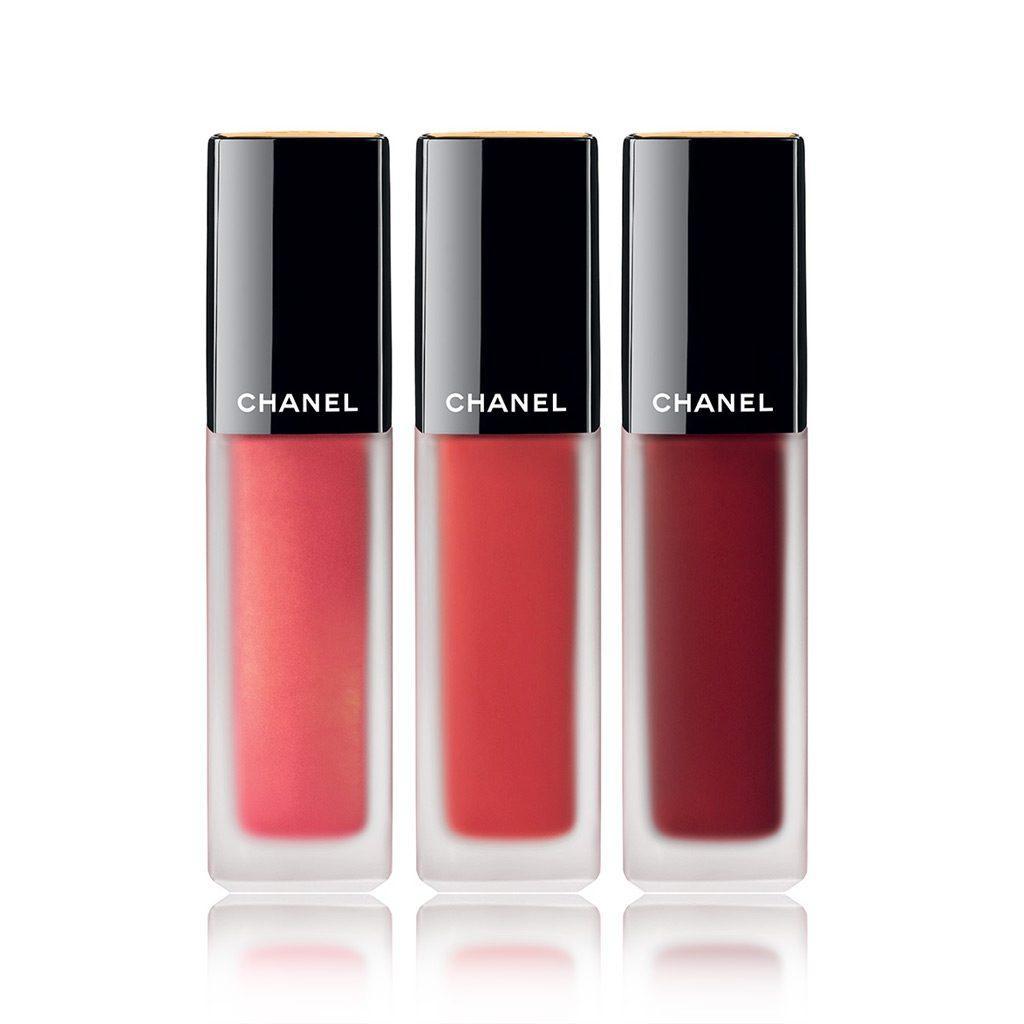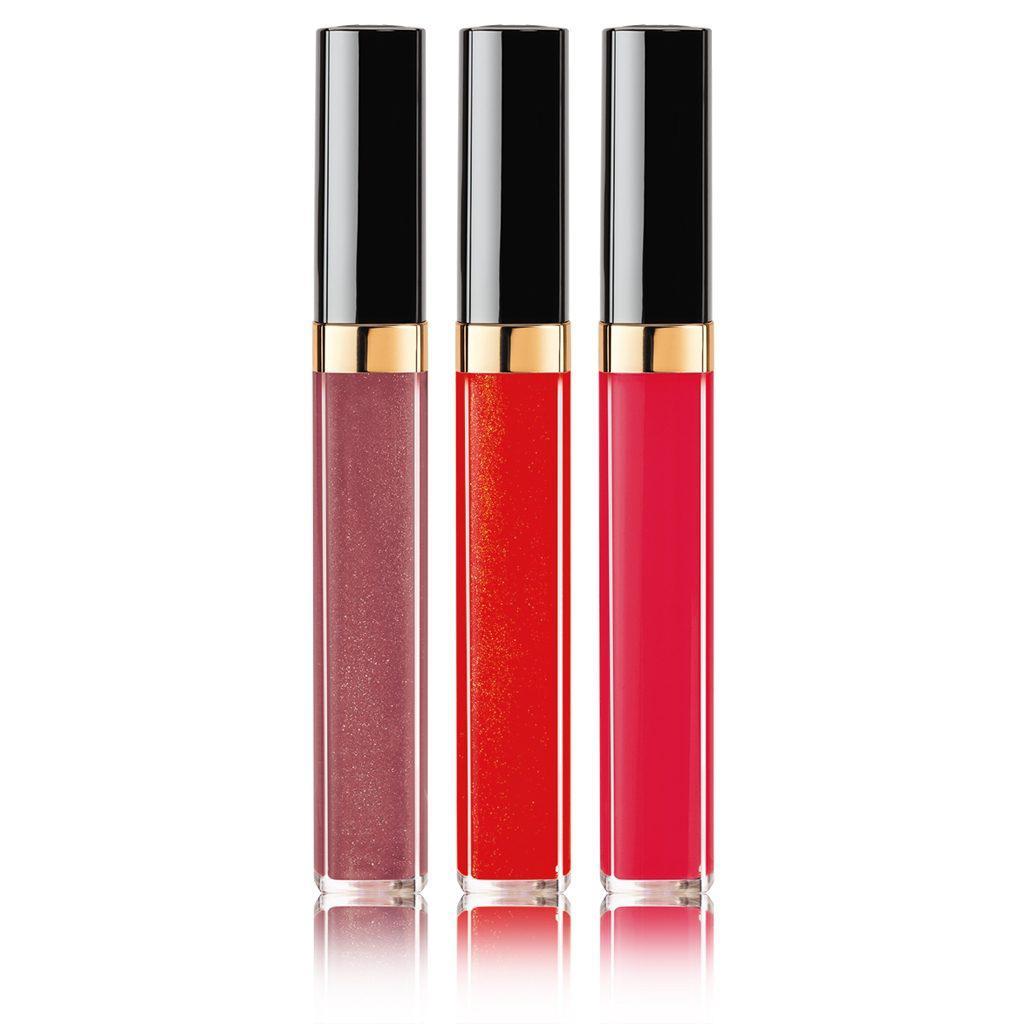The first image is the image on the left, the second image is the image on the right. For the images shown, is this caption "An image shows exactly one lip makeup item, displayed with its cap removed." true? Answer yes or no. No. The first image is the image on the left, the second image is the image on the right. Examine the images to the left and right. Is the description "lipsticks are shown with the lids off" accurate? Answer yes or no. No. 